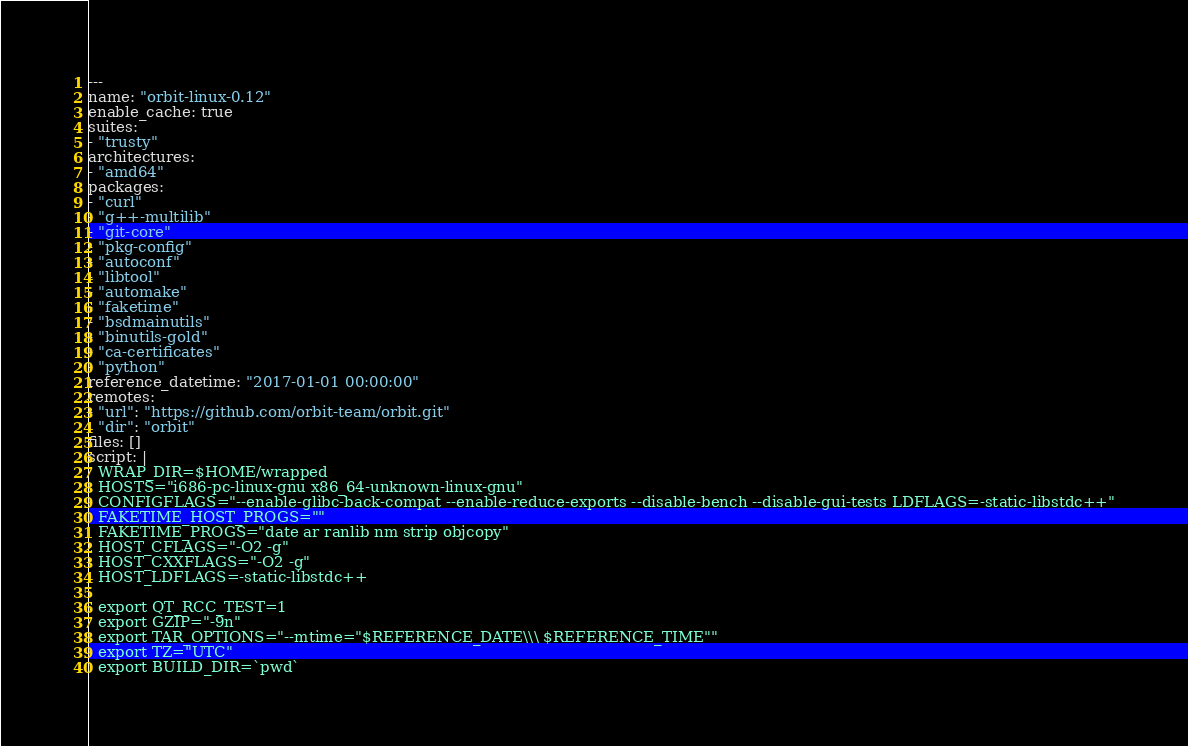Convert code to text. <code><loc_0><loc_0><loc_500><loc_500><_YAML_>---
name: "orbit-linux-0.12"
enable_cache: true
suites:
- "trusty"
architectures:
- "amd64"
packages:
- "curl"
- "g++-multilib"
- "git-core"
- "pkg-config"
- "autoconf"
- "libtool"
- "automake"
- "faketime"
- "bsdmainutils"
- "binutils-gold"
- "ca-certificates"
- "python"
reference_datetime: "2017-01-01 00:00:00"
remotes:
- "url": "https://github.com/orbit-team/orbit.git"
  "dir": "orbit"
files: []
script: |
  WRAP_DIR=$HOME/wrapped
  HOSTS="i686-pc-linux-gnu x86_64-unknown-linux-gnu"
  CONFIGFLAGS="--enable-glibc-back-compat --enable-reduce-exports --disable-bench --disable-gui-tests LDFLAGS=-static-libstdc++"
  FAKETIME_HOST_PROGS=""
  FAKETIME_PROGS="date ar ranlib nm strip objcopy"
  HOST_CFLAGS="-O2 -g"
  HOST_CXXFLAGS="-O2 -g"
  HOST_LDFLAGS=-static-libstdc++

  export QT_RCC_TEST=1
  export GZIP="-9n"
  export TAR_OPTIONS="--mtime="$REFERENCE_DATE\\\ $REFERENCE_TIME""
  export TZ="UTC"
  export BUILD_DIR=`pwd`</code> 